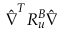Convert formula to latex. <formula><loc_0><loc_0><loc_500><loc_500>\hat { \nabla } ^ { T } R _ { u } ^ { B } \hat { \nabla }</formula> 